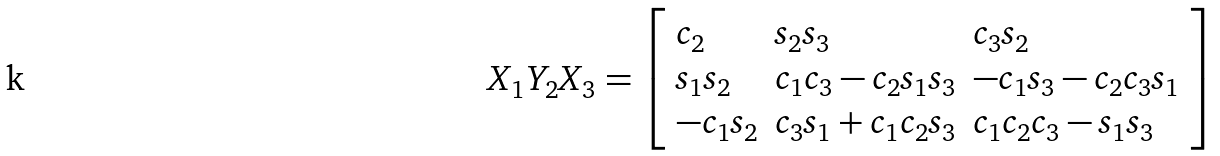<formula> <loc_0><loc_0><loc_500><loc_500>X _ { 1 } Y _ { 2 } X _ { 3 } = { \left [ \begin{array} { l l l } { c _ { 2 } } & { s _ { 2 } s _ { 3 } } & { c _ { 3 } s _ { 2 } } \\ { s _ { 1 } s _ { 2 } } & { c _ { 1 } c _ { 3 } - c _ { 2 } s _ { 1 } s _ { 3 } } & { - c _ { 1 } s _ { 3 } - c _ { 2 } c _ { 3 } s _ { 1 } } \\ { - c _ { 1 } s _ { 2 } } & { c _ { 3 } s _ { 1 } + c _ { 1 } c _ { 2 } s _ { 3 } } & { c _ { 1 } c _ { 2 } c _ { 3 } - s _ { 1 } s _ { 3 } } \end{array} \right ] }</formula> 